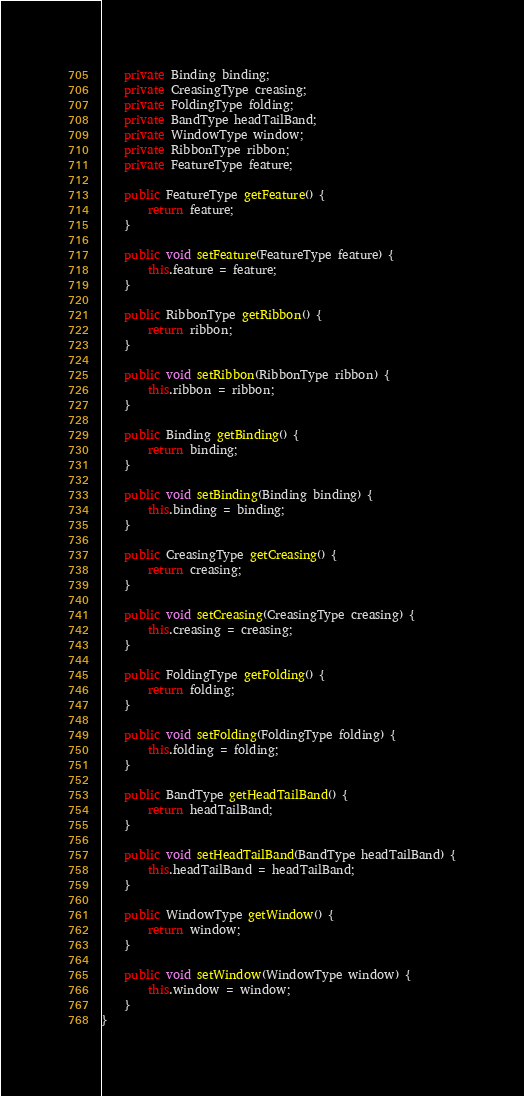Convert code to text. <code><loc_0><loc_0><loc_500><loc_500><_Java_>    private Binding binding;
    private CreasingType creasing;
    private FoldingType folding;
    private BandType headTailBand;
    private WindowType window;
    private RibbonType ribbon;
    private FeatureType feature;

    public FeatureType getFeature() {
        return feature;
    }

    public void setFeature(FeatureType feature) {
        this.feature = feature;
    }

    public RibbonType getRibbon() {
        return ribbon;
    }

    public void setRibbon(RibbonType ribbon) {
        this.ribbon = ribbon;
    }

    public Binding getBinding() {
        return binding;
    }

    public void setBinding(Binding binding) {
        this.binding = binding;
    }

    public CreasingType getCreasing() {
        return creasing;
    }

    public void setCreasing(CreasingType creasing) {
        this.creasing = creasing;
    }

    public FoldingType getFolding() {
        return folding;
    }

    public void setFolding(FoldingType folding) {
        this.folding = folding;
    }

    public BandType getHeadTailBand() {
        return headTailBand;
    }

    public void setHeadTailBand(BandType headTailBand) {
        this.headTailBand = headTailBand;
    }

    public WindowType getWindow() {
        return window;
    }

    public void setWindow(WindowType window) {
        this.window = window;
    }
}
</code> 